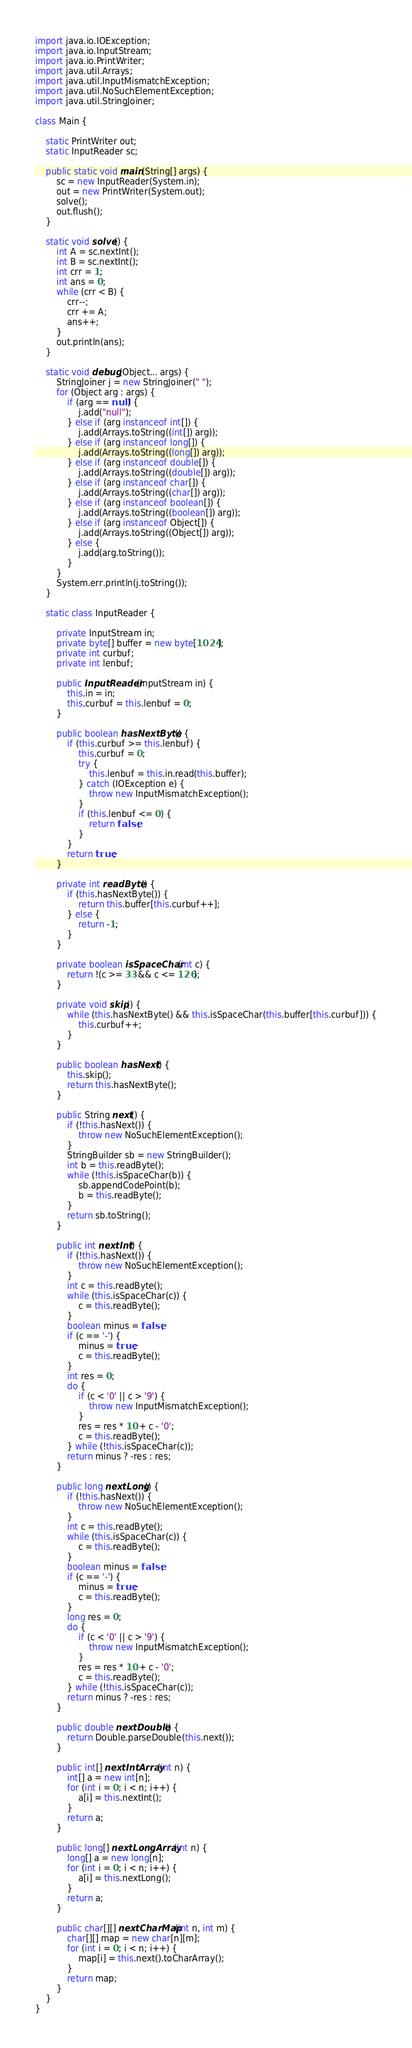<code> <loc_0><loc_0><loc_500><loc_500><_Java_>import java.io.IOException;
import java.io.InputStream;
import java.io.PrintWriter;
import java.util.Arrays;
import java.util.InputMismatchException;
import java.util.NoSuchElementException;
import java.util.StringJoiner;

class Main {

    static PrintWriter out;
    static InputReader sc;

    public static void main(String[] args) {
        sc = new InputReader(System.in);
        out = new PrintWriter(System.out);
        solve();
        out.flush();
    }

    static void solve() {
        int A = sc.nextInt();
        int B = sc.nextInt();
        int crr = 1;
        int ans = 0;
        while (crr < B) {
            crr--;
            crr += A;
            ans++;
        }
        out.println(ans);
    }

    static void debug(Object... args) {
        StringJoiner j = new StringJoiner(" ");
        for (Object arg : args) {
            if (arg == null) {
                j.add("null");
            } else if (arg instanceof int[]) {
                j.add(Arrays.toString((int[]) arg));
            } else if (arg instanceof long[]) {
                j.add(Arrays.toString((long[]) arg));
            } else if (arg instanceof double[]) {
                j.add(Arrays.toString((double[]) arg));
            } else if (arg instanceof char[]) {
                j.add(Arrays.toString((char[]) arg));
            } else if (arg instanceof boolean[]) {
                j.add(Arrays.toString((boolean[]) arg));
            } else if (arg instanceof Object[]) {
                j.add(Arrays.toString((Object[]) arg));
            } else {
                j.add(arg.toString());
            }
        }
        System.err.println(j.toString());
    }

    static class InputReader {

        private InputStream in;
        private byte[] buffer = new byte[1024];
        private int curbuf;
        private int lenbuf;

        public InputReader(InputStream in) {
            this.in = in;
            this.curbuf = this.lenbuf = 0;
        }

        public boolean hasNextByte() {
            if (this.curbuf >= this.lenbuf) {
                this.curbuf = 0;
                try {
                    this.lenbuf = this.in.read(this.buffer);
                } catch (IOException e) {
                    throw new InputMismatchException();
                }
                if (this.lenbuf <= 0) {
                    return false;
                }
            }
            return true;
        }

        private int readByte() {
            if (this.hasNextByte()) {
                return this.buffer[this.curbuf++];
            } else {
                return -1;
            }
        }

        private boolean isSpaceChar(int c) {
            return !(c >= 33 && c <= 126);
        }

        private void skip() {
            while (this.hasNextByte() && this.isSpaceChar(this.buffer[this.curbuf])) {
                this.curbuf++;
            }
        }

        public boolean hasNext() {
            this.skip();
            return this.hasNextByte();
        }

        public String next() {
            if (!this.hasNext()) {
                throw new NoSuchElementException();
            }
            StringBuilder sb = new StringBuilder();
            int b = this.readByte();
            while (!this.isSpaceChar(b)) {
                sb.appendCodePoint(b);
                b = this.readByte();
            }
            return sb.toString();
        }

        public int nextInt() {
            if (!this.hasNext()) {
                throw new NoSuchElementException();
            }
            int c = this.readByte();
            while (this.isSpaceChar(c)) {
                c = this.readByte();
            }
            boolean minus = false;
            if (c == '-') {
                minus = true;
                c = this.readByte();
            }
            int res = 0;
            do {
                if (c < '0' || c > '9') {
                    throw new InputMismatchException();
                }
                res = res * 10 + c - '0';
                c = this.readByte();
            } while (!this.isSpaceChar(c));
            return minus ? -res : res;
        }

        public long nextLong() {
            if (!this.hasNext()) {
                throw new NoSuchElementException();
            }
            int c = this.readByte();
            while (this.isSpaceChar(c)) {
                c = this.readByte();
            }
            boolean minus = false;
            if (c == '-') {
                minus = true;
                c = this.readByte();
            }
            long res = 0;
            do {
                if (c < '0' || c > '9') {
                    throw new InputMismatchException();
                }
                res = res * 10 + c - '0';
                c = this.readByte();
            } while (!this.isSpaceChar(c));
            return minus ? -res : res;
        }

        public double nextDouble() {
            return Double.parseDouble(this.next());
        }

        public int[] nextIntArray(int n) {
            int[] a = new int[n];
            for (int i = 0; i < n; i++) {
                a[i] = this.nextInt();
            }
            return a;
        }

        public long[] nextLongArray(int n) {
            long[] a = new long[n];
            for (int i = 0; i < n; i++) {
                a[i] = this.nextLong();
            }
            return a;
        }

        public char[][] nextCharMap(int n, int m) {
            char[][] map = new char[n][m];
            for (int i = 0; i < n; i++) {
                map[i] = this.next().toCharArray();
            }
            return map;
        }
    }
}</code> 